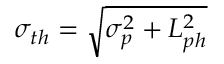<formula> <loc_0><loc_0><loc_500><loc_500>\sigma _ { t h } = \sqrt { \sigma _ { p } ^ { 2 } + L _ { p h } ^ { 2 } }</formula> 